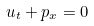Convert formula to latex. <formula><loc_0><loc_0><loc_500><loc_500>u _ { t } + p _ { x } = 0</formula> 